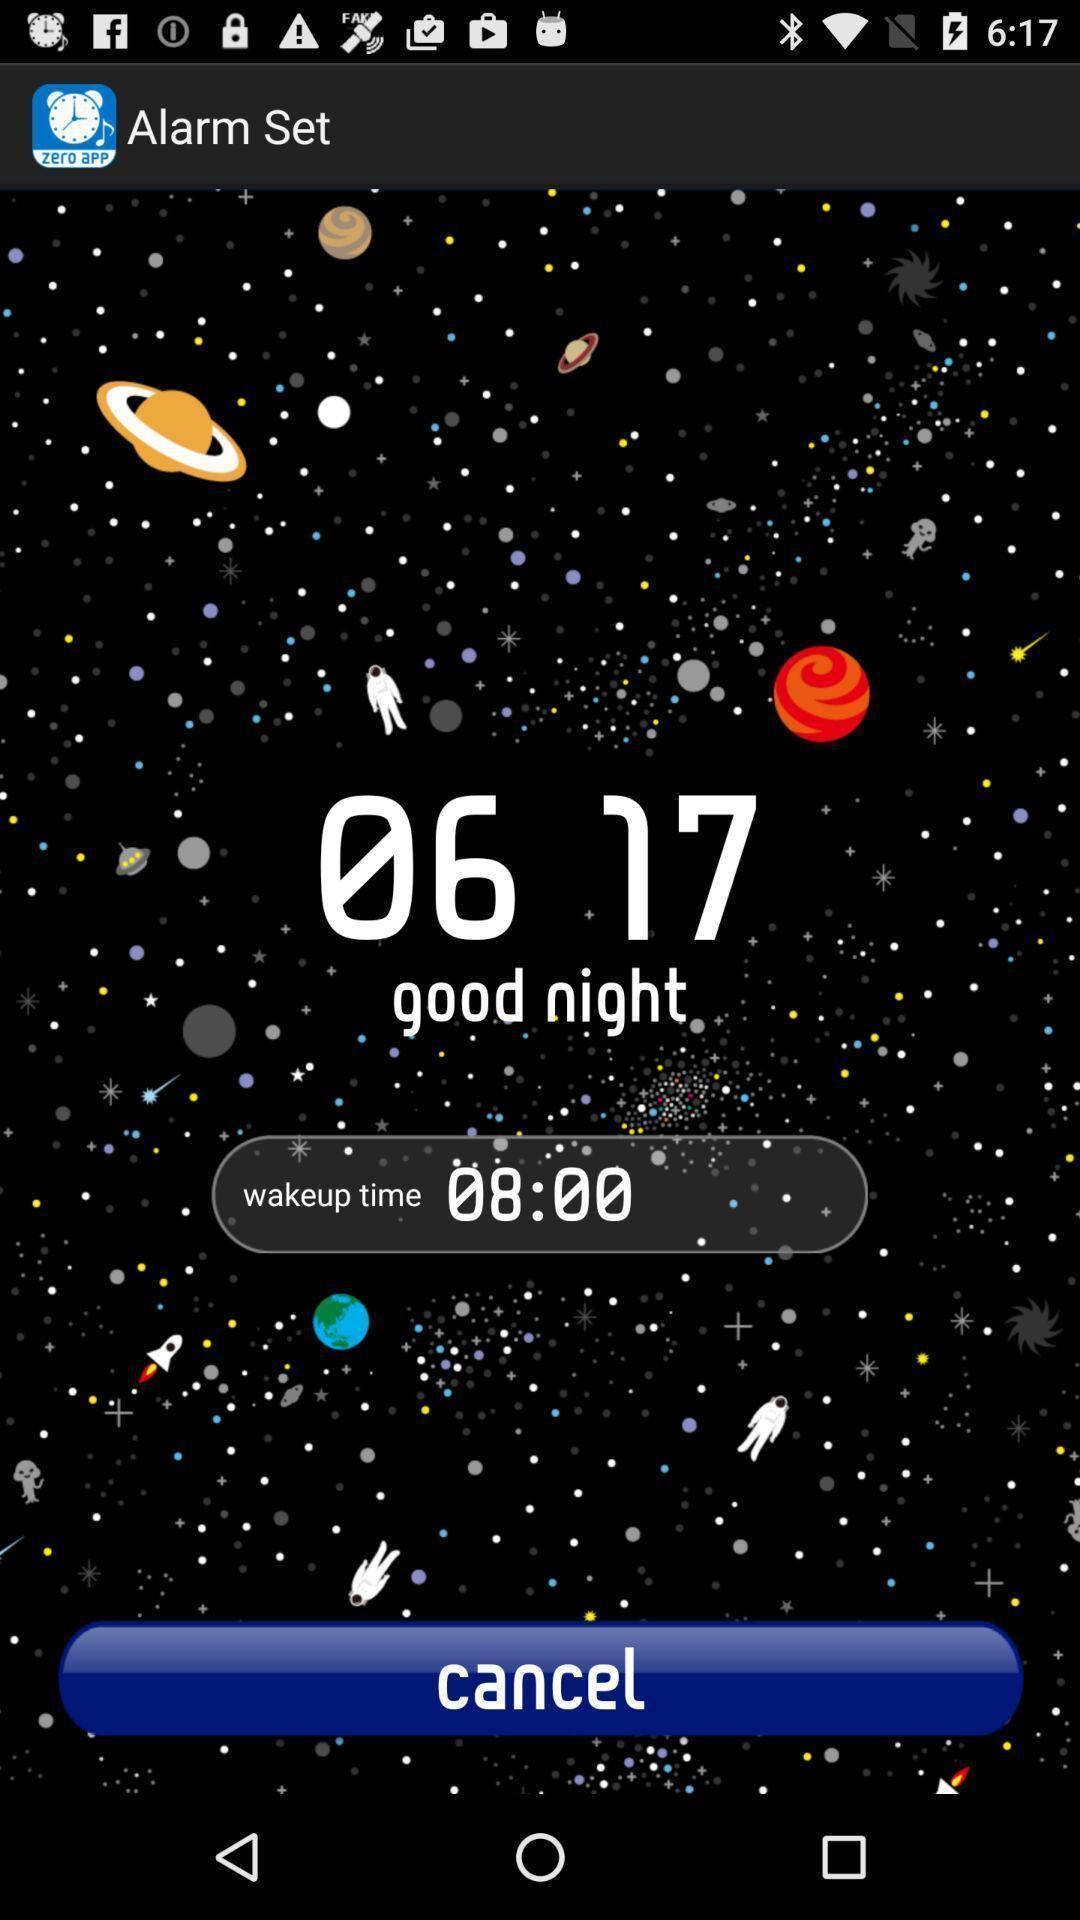Provide a description of this screenshot. Page displaying the alarm timing. 